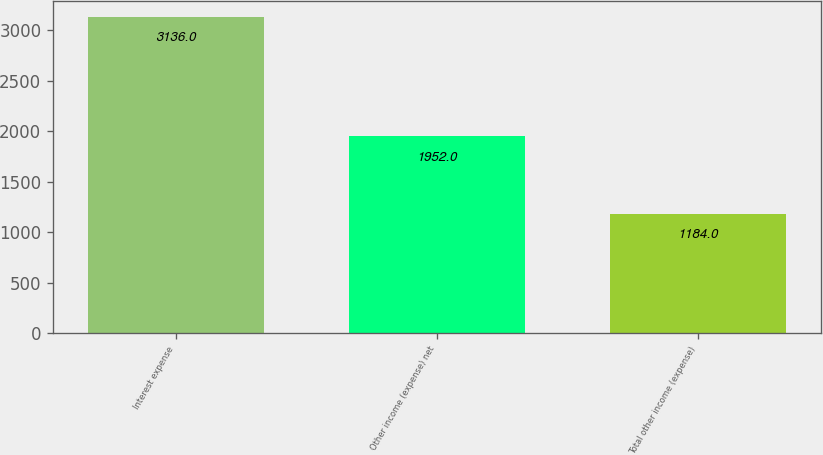<chart> <loc_0><loc_0><loc_500><loc_500><bar_chart><fcel>Interest expense<fcel>Other income (expense) net<fcel>Total other income (expense)<nl><fcel>3136<fcel>1952<fcel>1184<nl></chart> 